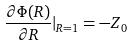Convert formula to latex. <formula><loc_0><loc_0><loc_500><loc_500>\frac { \partial \Phi ( R ) } { \partial R } | _ { R = 1 } = - Z _ { 0 }</formula> 